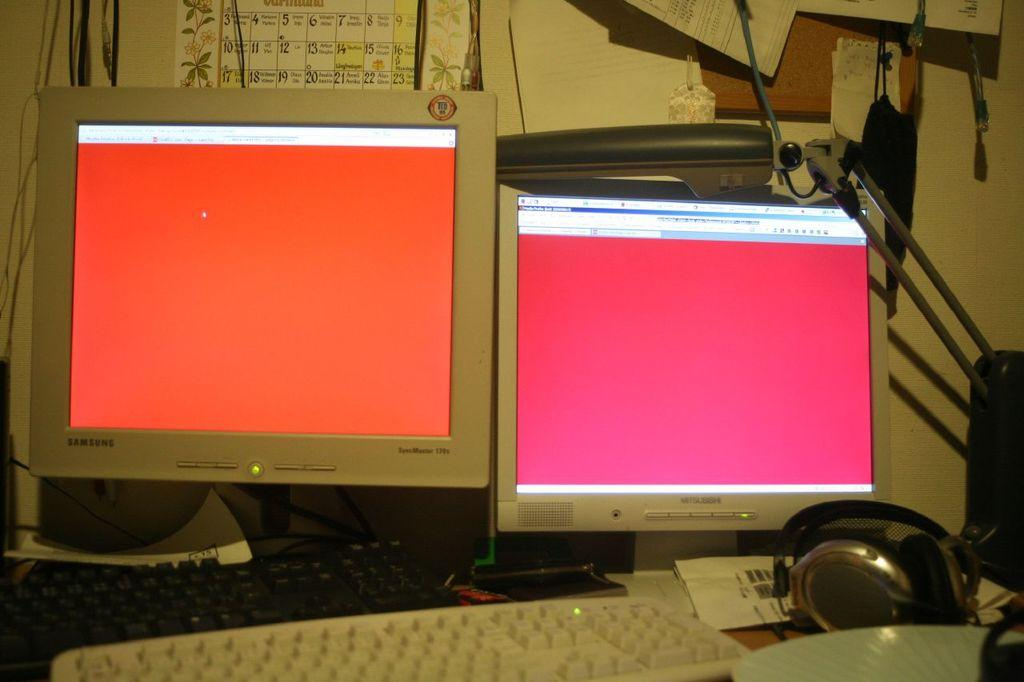Provide a one-sentence caption for the provided image. Samsung and Mitsubishi monitors sit side by side on the desk. 